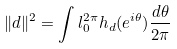<formula> <loc_0><loc_0><loc_500><loc_500>\| d \| ^ { 2 } = \int l ^ { 2 \pi } _ { 0 } h _ { d } ( e ^ { i \theta } ) \frac { d \theta } { 2 \pi }</formula> 